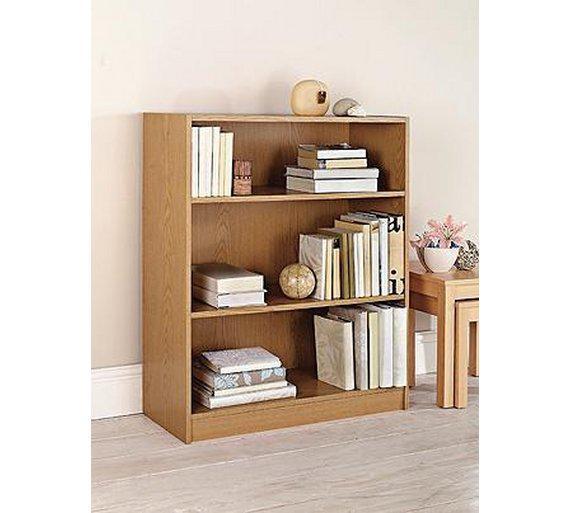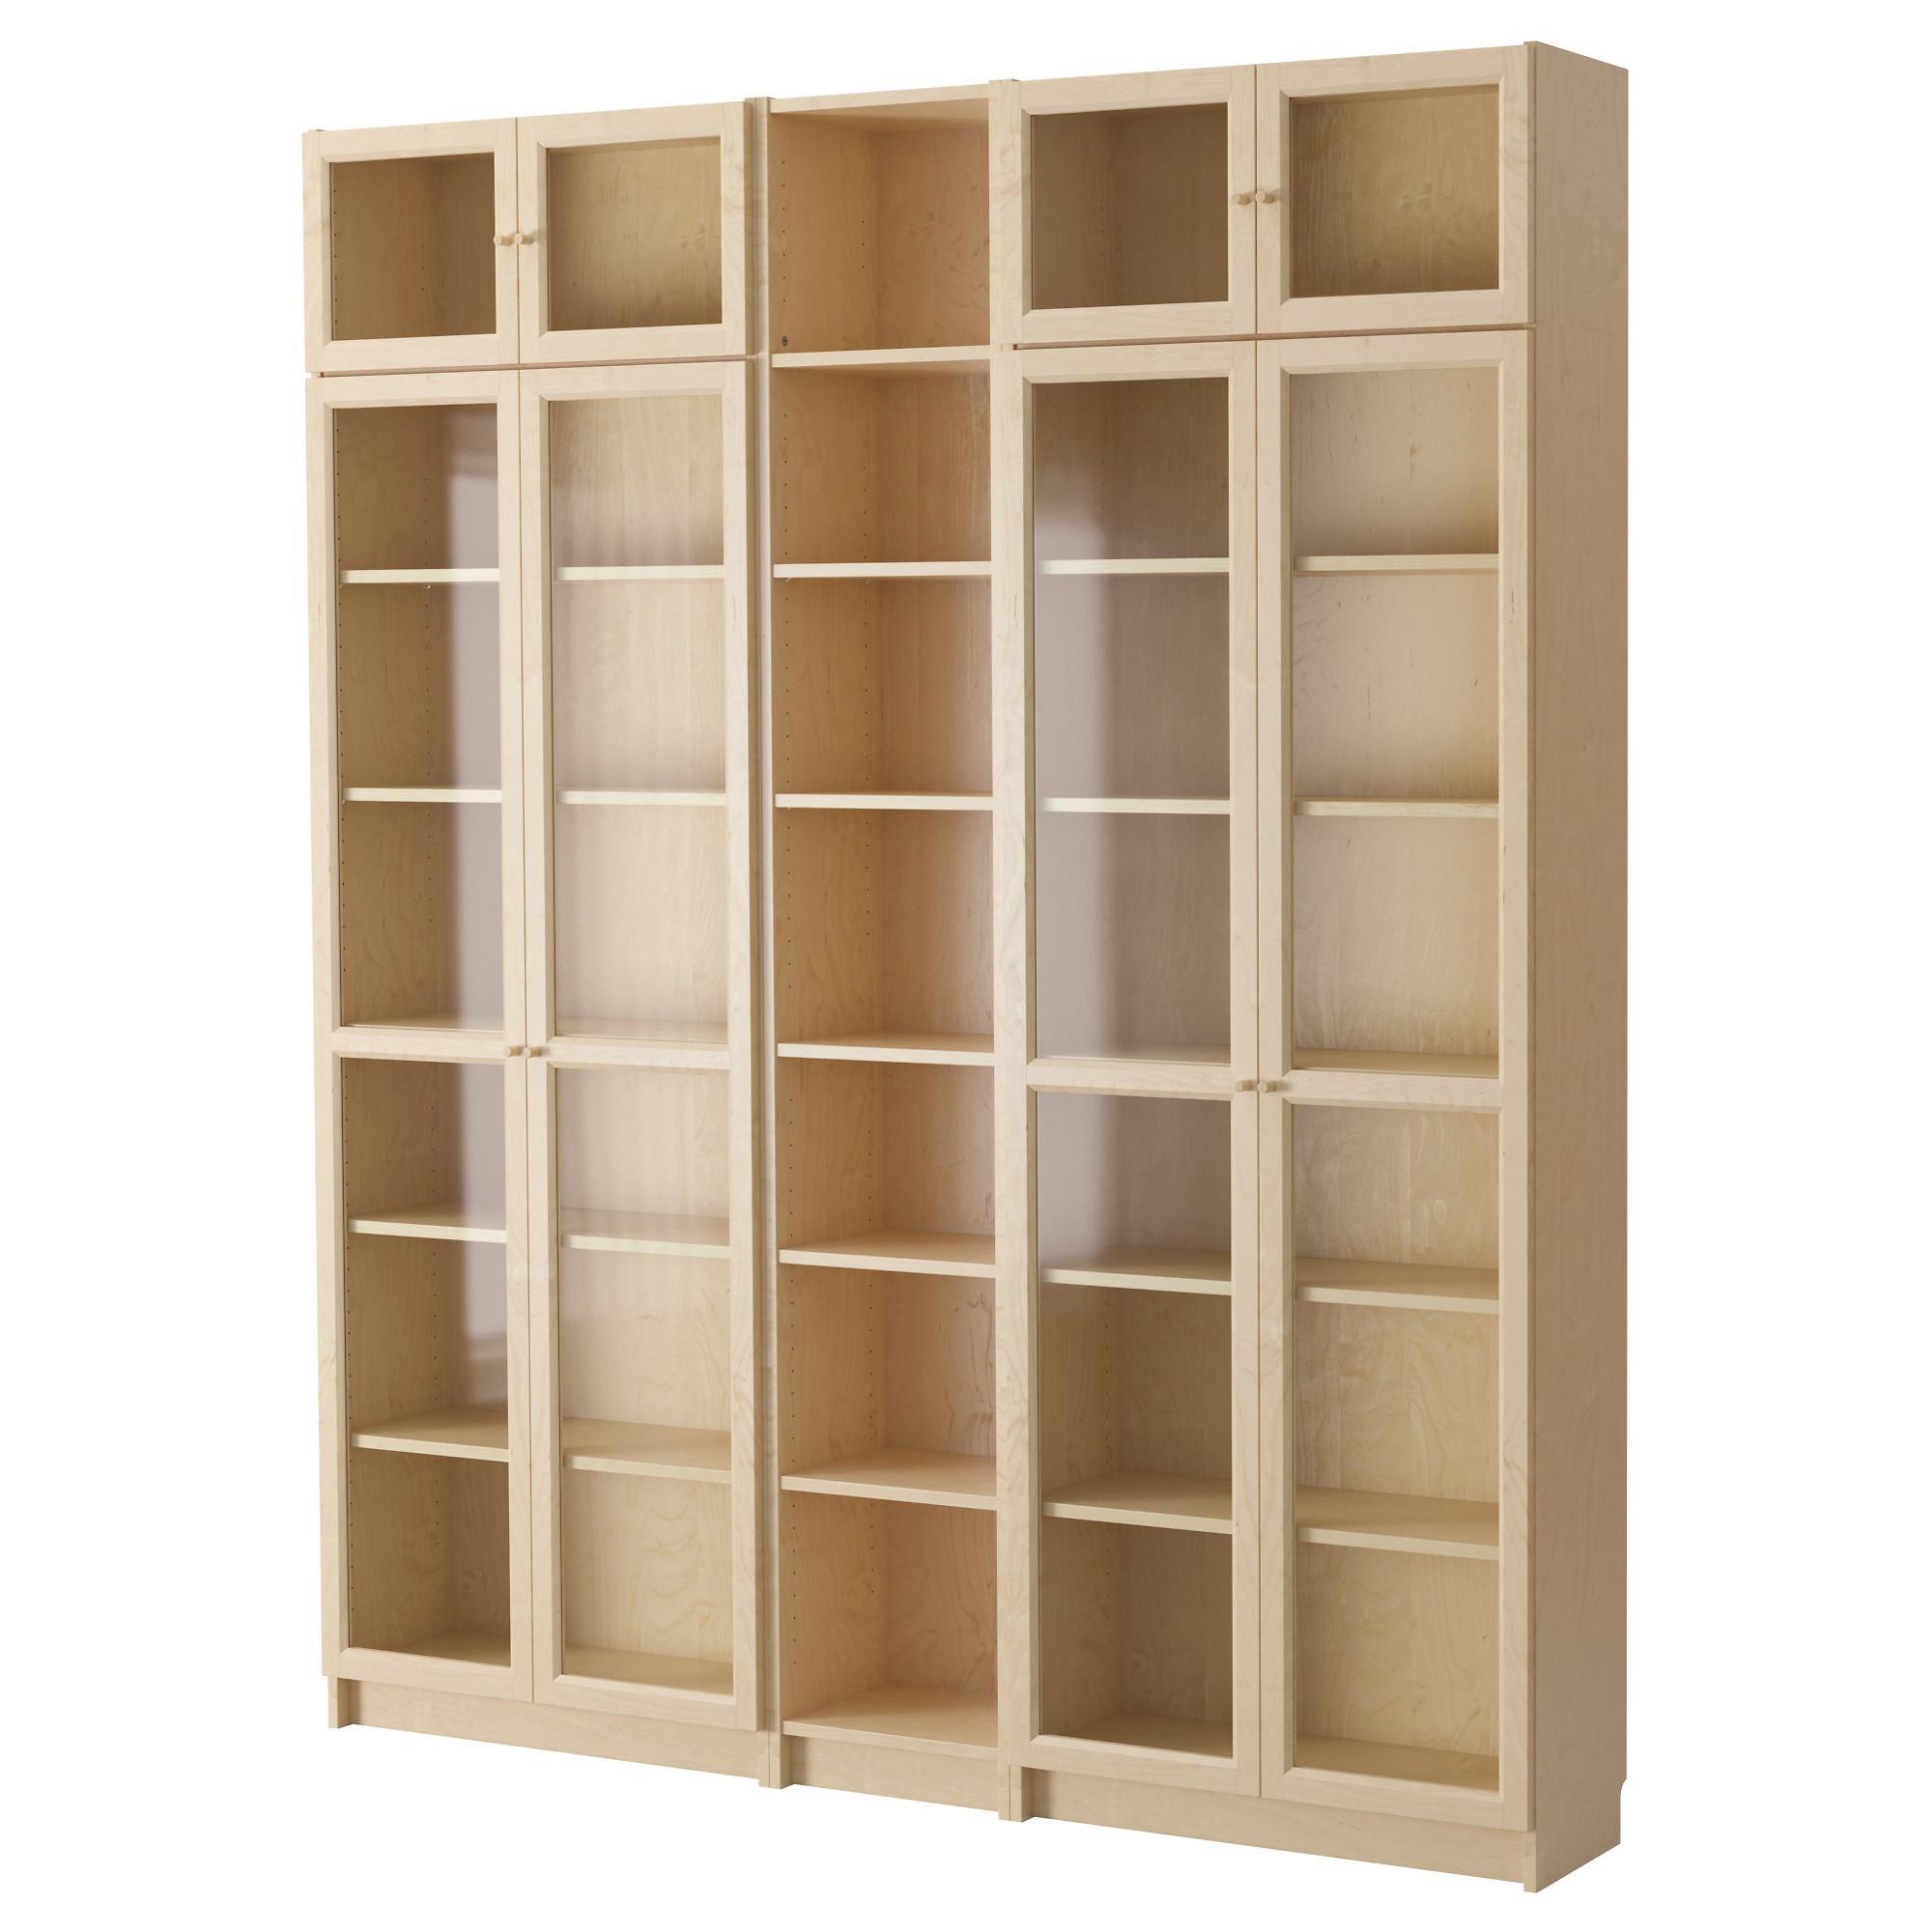The first image is the image on the left, the second image is the image on the right. Given the left and right images, does the statement "One tall narrow bookcase is on short legs and one is flush to the floor." hold true? Answer yes or no. No. 